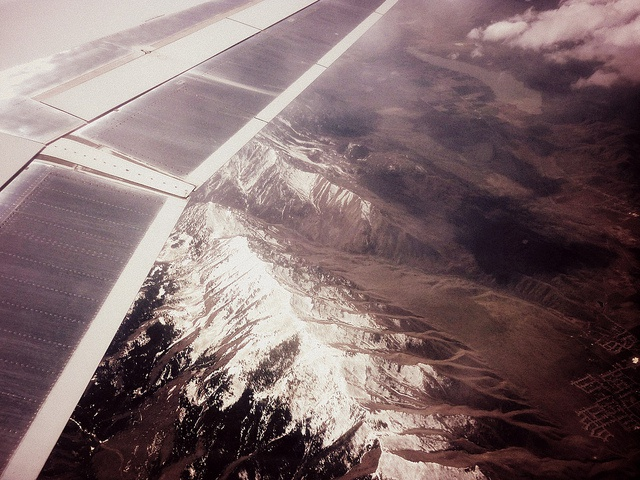Describe the objects in this image and their specific colors. I can see a airplane in darkgray, lightgray, and gray tones in this image. 